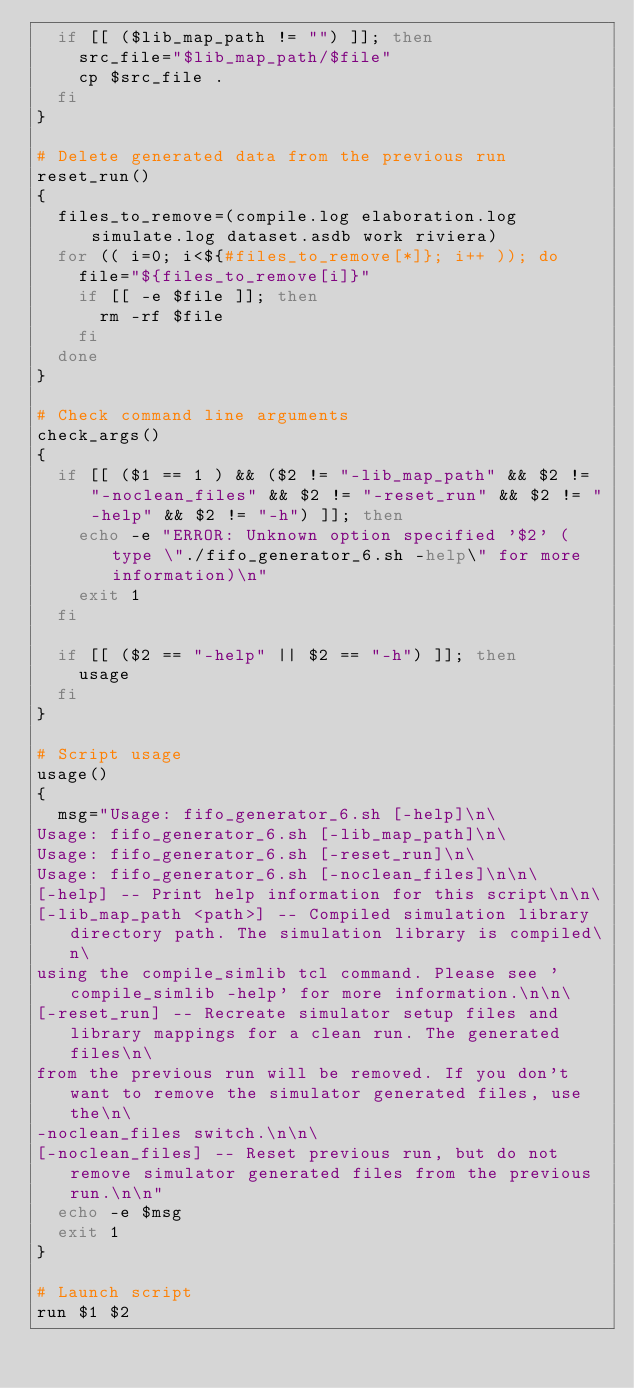Convert code to text. <code><loc_0><loc_0><loc_500><loc_500><_Bash_>  if [[ ($lib_map_path != "") ]]; then
    src_file="$lib_map_path/$file"
    cp $src_file .
  fi
}

# Delete generated data from the previous run
reset_run()
{
  files_to_remove=(compile.log elaboration.log simulate.log dataset.asdb work riviera)
  for (( i=0; i<${#files_to_remove[*]}; i++ )); do
    file="${files_to_remove[i]}"
    if [[ -e $file ]]; then
      rm -rf $file
    fi
  done
}

# Check command line arguments
check_args()
{
  if [[ ($1 == 1 ) && ($2 != "-lib_map_path" && $2 != "-noclean_files" && $2 != "-reset_run" && $2 != "-help" && $2 != "-h") ]]; then
    echo -e "ERROR: Unknown option specified '$2' (type \"./fifo_generator_6.sh -help\" for more information)\n"
    exit 1
  fi

  if [[ ($2 == "-help" || $2 == "-h") ]]; then
    usage
  fi
}

# Script usage
usage()
{
  msg="Usage: fifo_generator_6.sh [-help]\n\
Usage: fifo_generator_6.sh [-lib_map_path]\n\
Usage: fifo_generator_6.sh [-reset_run]\n\
Usage: fifo_generator_6.sh [-noclean_files]\n\n\
[-help] -- Print help information for this script\n\n\
[-lib_map_path <path>] -- Compiled simulation library directory path. The simulation library is compiled\n\
using the compile_simlib tcl command. Please see 'compile_simlib -help' for more information.\n\n\
[-reset_run] -- Recreate simulator setup files and library mappings for a clean run. The generated files\n\
from the previous run will be removed. If you don't want to remove the simulator generated files, use the\n\
-noclean_files switch.\n\n\
[-noclean_files] -- Reset previous run, but do not remove simulator generated files from the previous run.\n\n"
  echo -e $msg
  exit 1
}

# Launch script
run $1 $2
</code> 